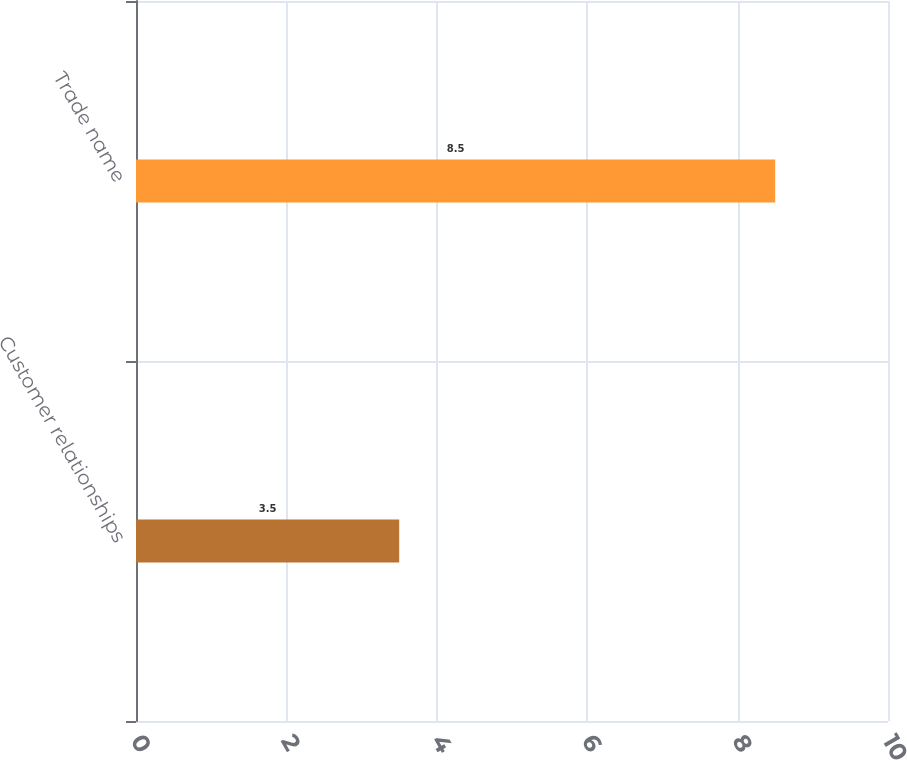Convert chart. <chart><loc_0><loc_0><loc_500><loc_500><bar_chart><fcel>Customer relationships<fcel>Trade name<nl><fcel>3.5<fcel>8.5<nl></chart> 